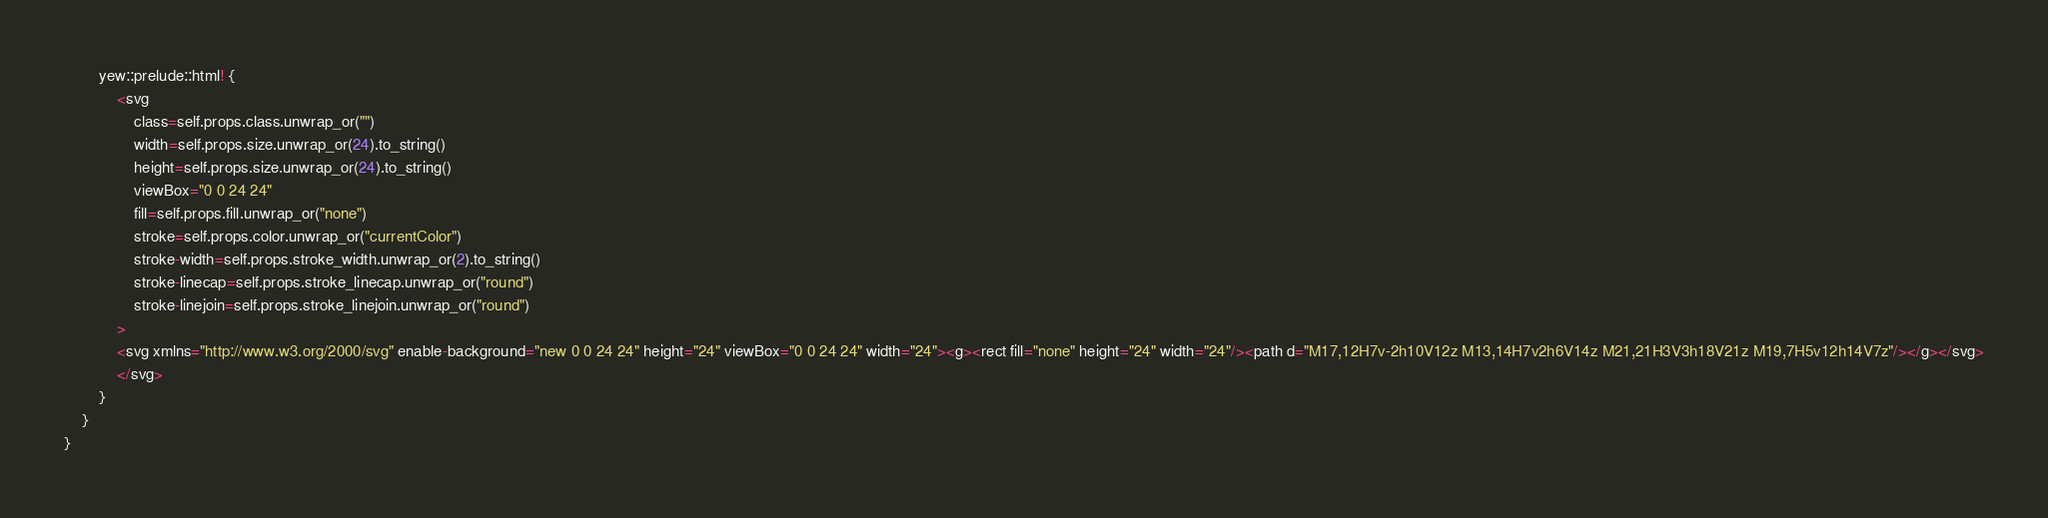<code> <loc_0><loc_0><loc_500><loc_500><_Rust_>        yew::prelude::html! {
            <svg
                class=self.props.class.unwrap_or("")
                width=self.props.size.unwrap_or(24).to_string()
                height=self.props.size.unwrap_or(24).to_string()
                viewBox="0 0 24 24"
                fill=self.props.fill.unwrap_or("none")
                stroke=self.props.color.unwrap_or("currentColor")
                stroke-width=self.props.stroke_width.unwrap_or(2).to_string()
                stroke-linecap=self.props.stroke_linecap.unwrap_or("round")
                stroke-linejoin=self.props.stroke_linejoin.unwrap_or("round")
            >
            <svg xmlns="http://www.w3.org/2000/svg" enable-background="new 0 0 24 24" height="24" viewBox="0 0 24 24" width="24"><g><rect fill="none" height="24" width="24"/><path d="M17,12H7v-2h10V12z M13,14H7v2h6V14z M21,21H3V3h18V21z M19,7H5v12h14V7z"/></g></svg>
            </svg>
        }
    }
}


</code> 